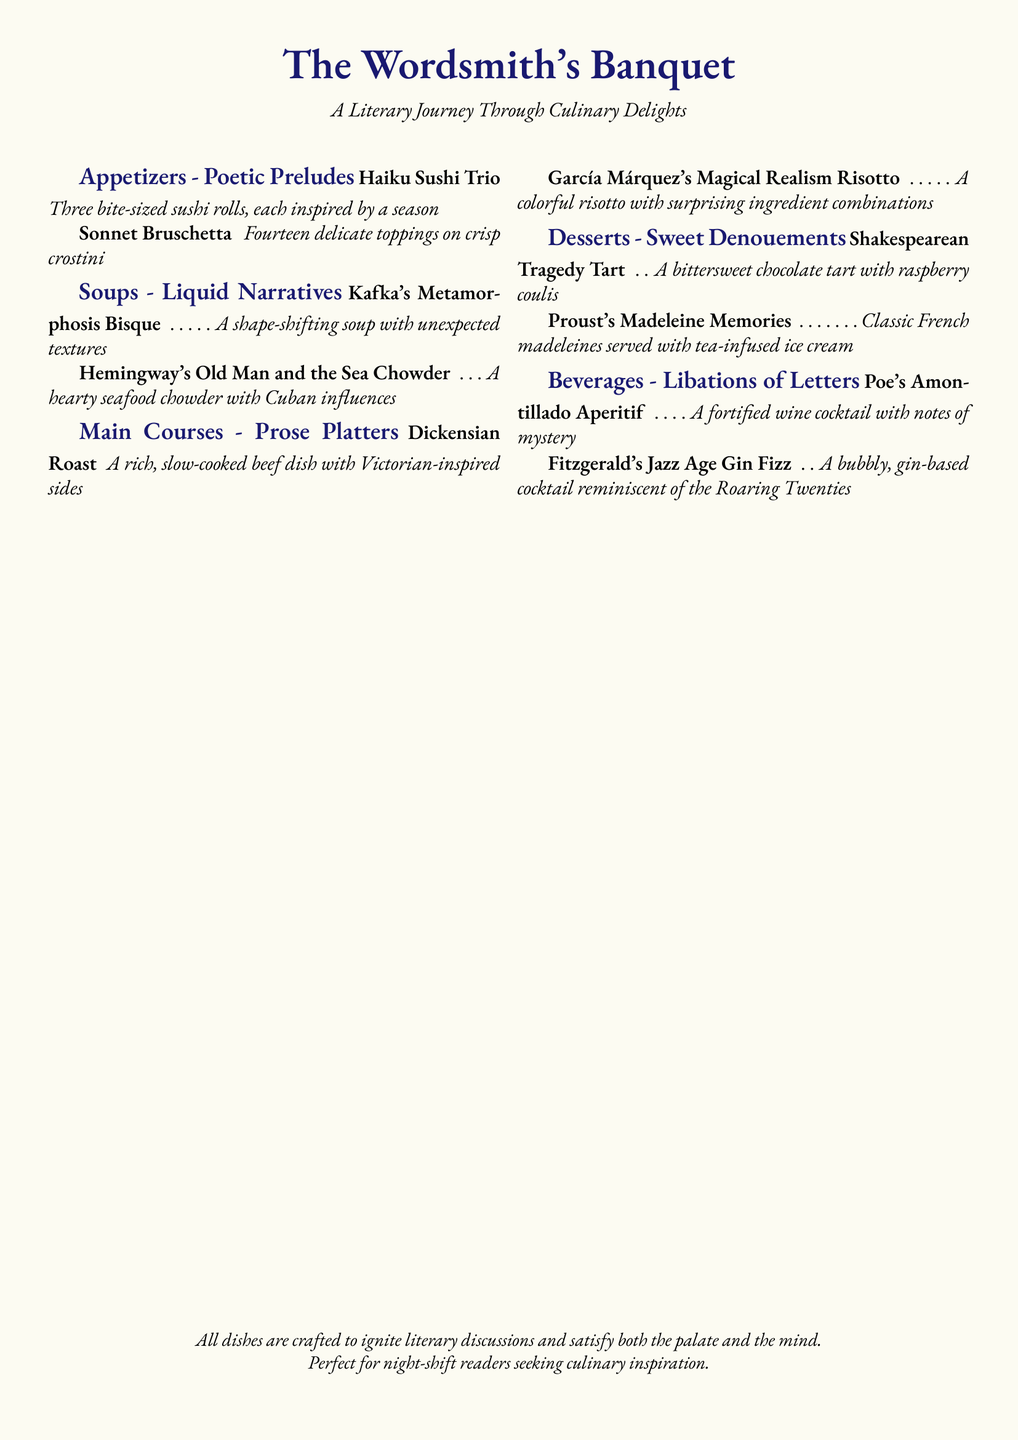What is the title of the menu? The title of the menu is indicated at the top of the document.
Answer: The Wordsmith's Banquet What genre is the "Kafka's Metamorphosis Bisque" inspired by? The dish is categorized under the "Soups" section, specifically inspired by a literary work, Kafka's Metamorphosis.
Answer: Liquid Narratives How many appetizers are listed in the menu? There are two appetizers mentioned under the "Appetizers - Poetic Preludes" section.
Answer: Two What beverage is associated with Fitzgerald? The beverage section indicates a cocktail associated with Fitzgerald.
Answer: Fitzgerald's Jazz Age Gin Fizz What type of dessert is "Proust's Madeleine Memories"? The dessert is categorized under "Desserts - Sweet Denouements" and is related to Proust.
Answer: Classic French madeleines Which course features "García Márquez's Magical Realism Risotto"? The dish is included in the "Main Courses - Prose Platters" section.
Answer: Main Courses What is the flavor profile of the "Shakespearean Tragedy Tart"? The flavor profile is indicated in the description of the dessert, highlighting its taste experience.
Answer: Bittersweet chocolate What theme does the overall menu intend to evoke? The document's introduction mentions the thematic intention behind the culinary selections.
Answer: Literary Journey Through Culinary Delights What is the color of the page background? The background color is specified in the page setup of the document.
Answer: Pale gold 